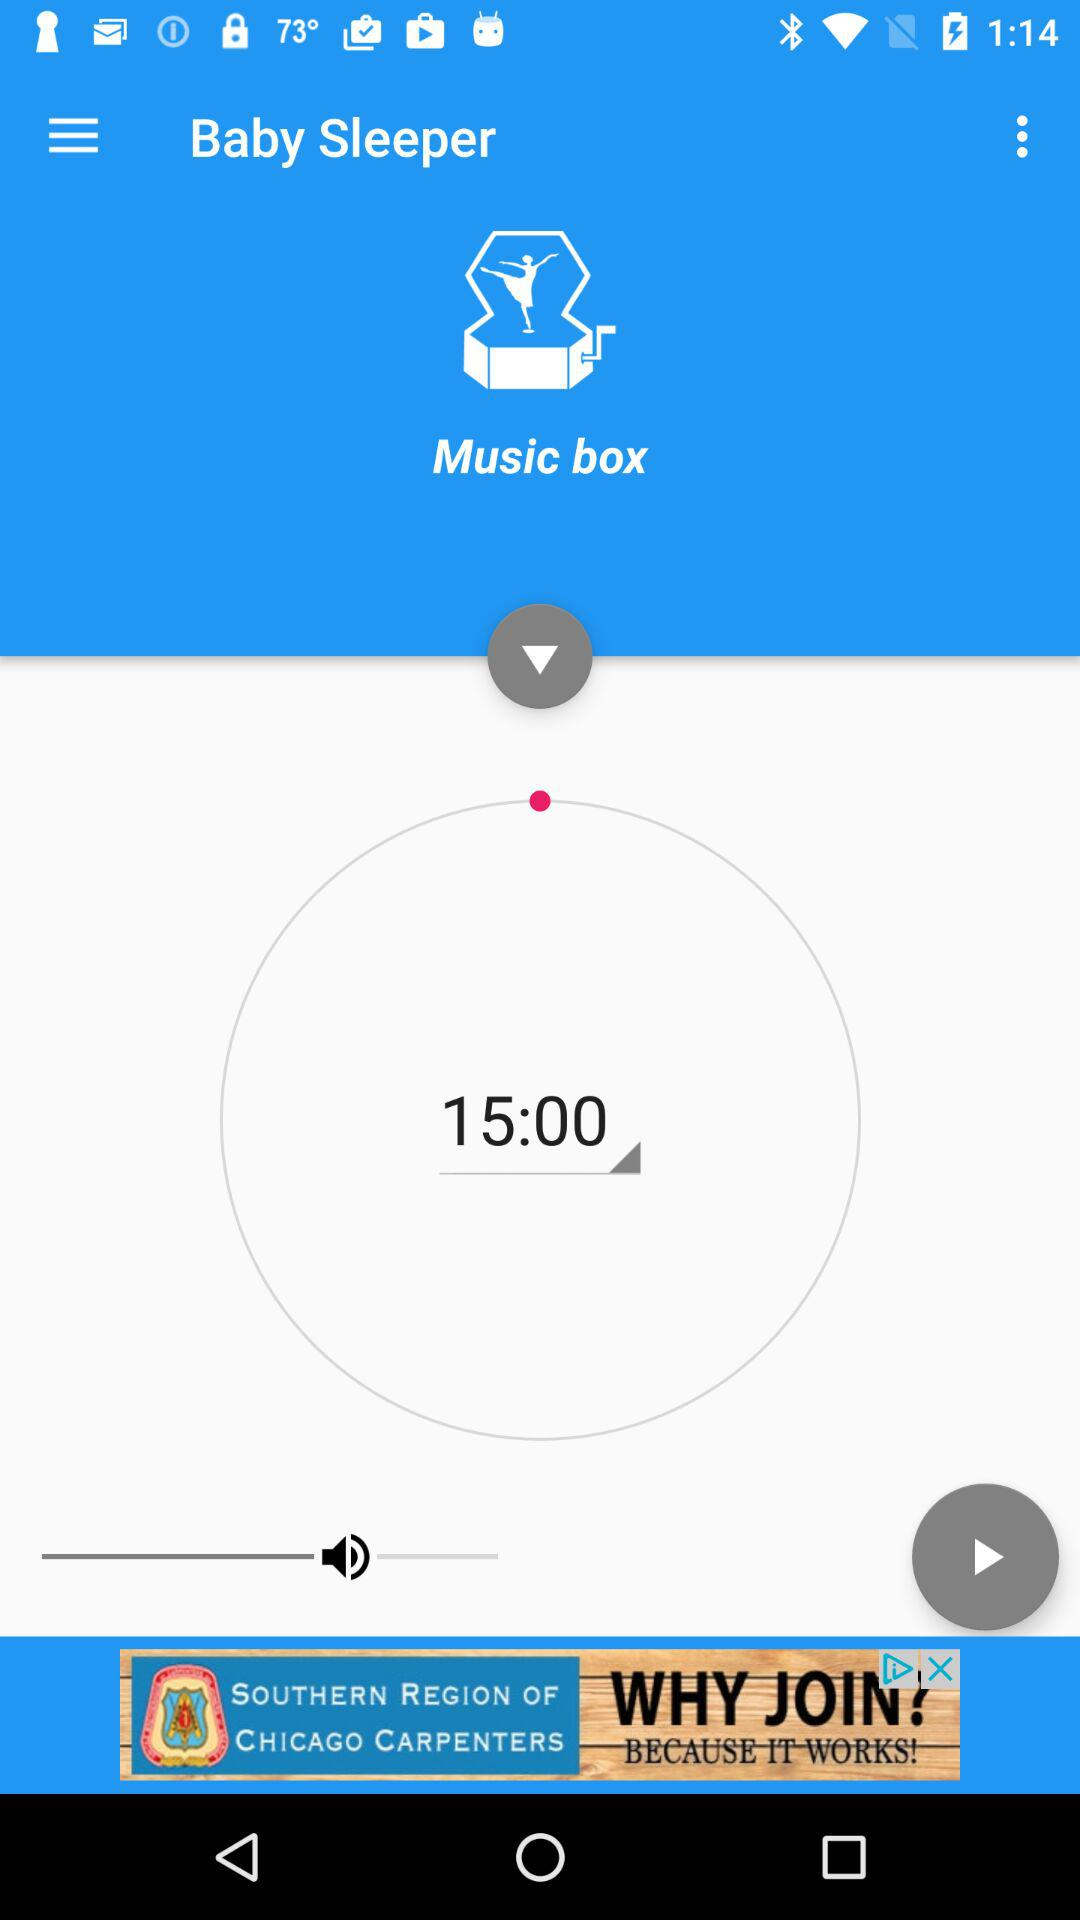What is the selected time? The selected time is 15:00. 